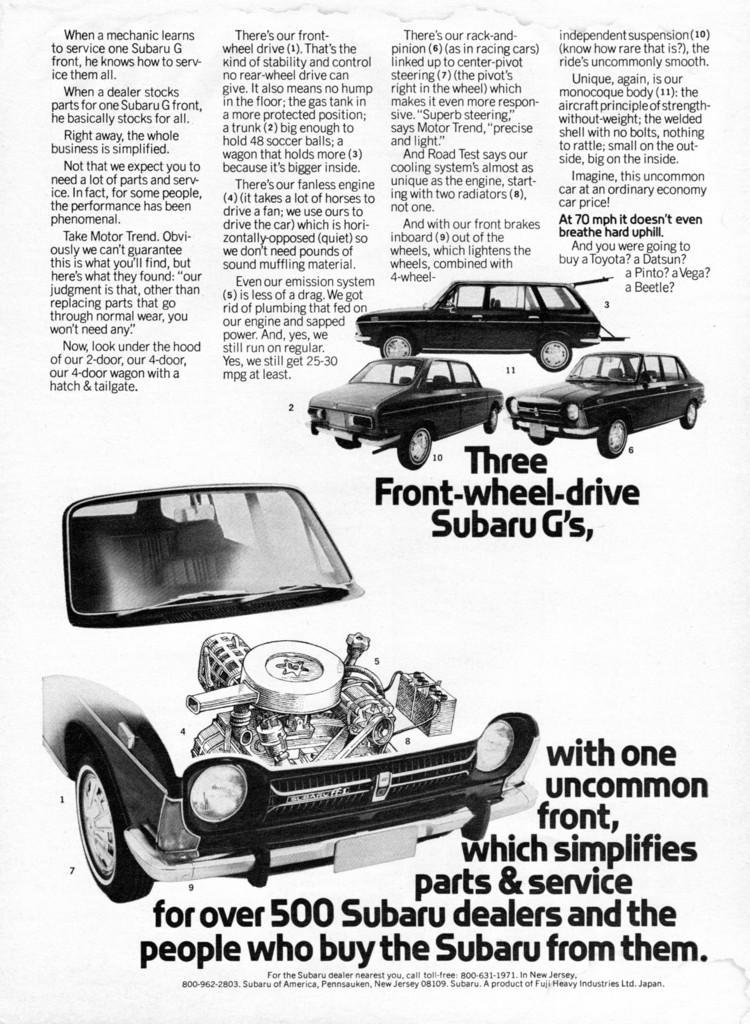Can you describe this image briefly? In this image we can see an article of a vehicle and there are images and are described about those. 